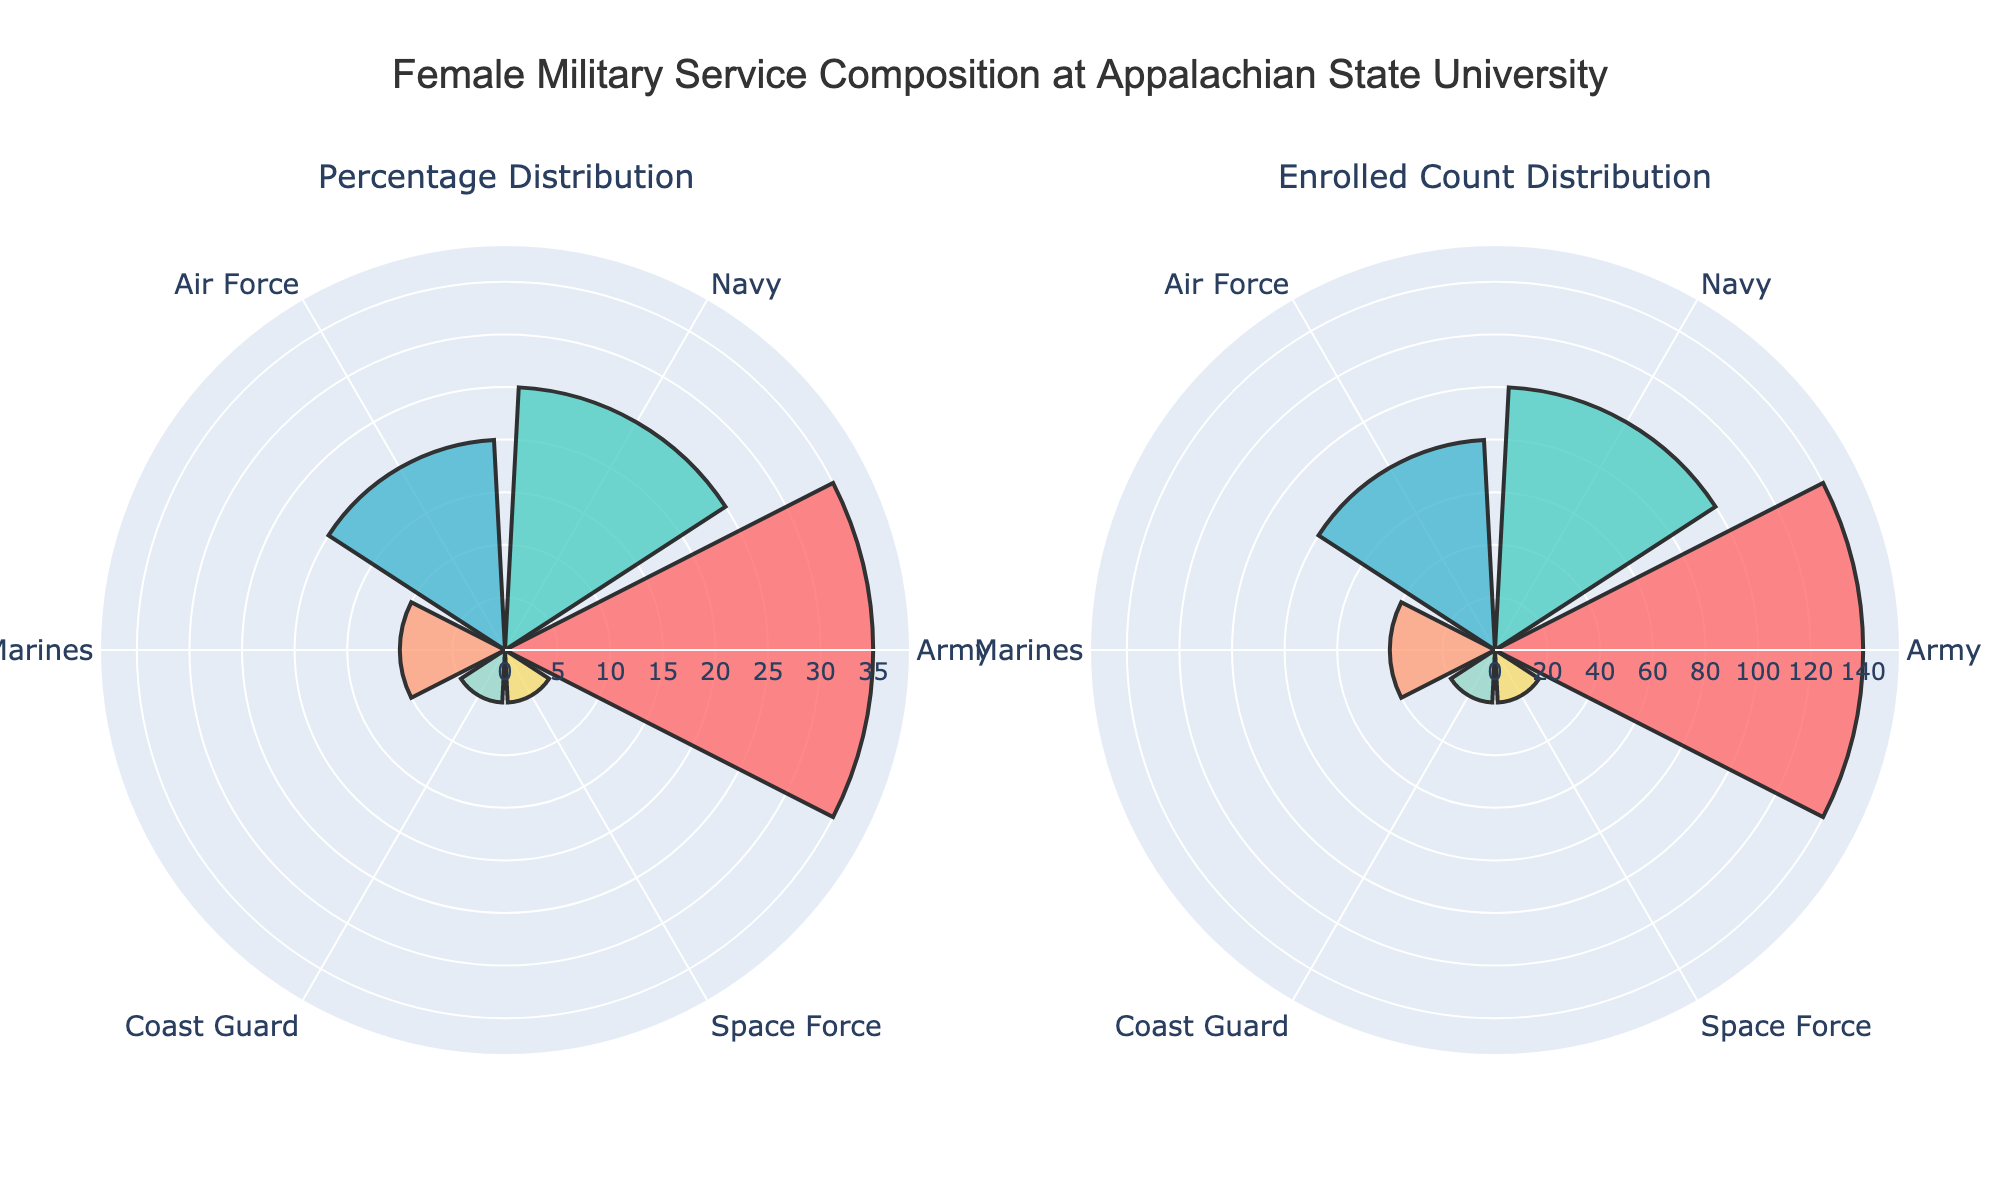How many service branches are represented in the plots? Count the number of different service branches shown in either of the polar charts. Both charts represent the same branches. A quick look shows six different service branches.
Answer: Six What is the highest percentage for any service branch? Look at the "Percentage Distribution" plot and identify the bar with the maximum radial length (height). The Army has the highest bar at 35%.
Answer: 35% Which service branch has the lowest enrolled count? Refer to the "Enrolled Count Distribution" plot and find the bar with the shortest radial length. Both the Coast Guard and Space Force have the lowest counts of 20.
Answer: Coast Guard and Space Force What service branch has the second largest percentage distribution? Identify the second highest bar in the "Percentage Distribution" plot. The Navy has the second largest percentage at 25%.
Answer: Navy What is the total enrolled count across all service branches? Sum the enrolled counts of all the branches from the "Enrolled Count Distribution" plot: 140 (Army) + 100 (Navy) + 80 (Air Force) + 40 (Marines) + 20 (Coast Guard) + 20 (Space Force) = 400.
Answer: 400 Which two service branches have the exact same percentage? Look for identical radial lengths in the "Percentage Distribution" plot. Both the Coast Guard and Space Force have percentages of 5%.
Answer: Coast Guard and Space Force How does the Marines' percentage compare to the Air Force's percentage? Compare the radial lengths of the Marines (10%) and the Air Force (20%) in the "Percentage Distribution" plot. The Air Force's percentage is twice that of the Marines.
Answer: Air Force is higher What's the total percentage of students from the Army and Navy combined? Add the percentages from the "Percentage Distribution" plot: Army (35%) + Navy (25%) = 60%.
Answer: 60% Which service branch has a higher enrolled count, Marines or Air Force? Look at the "Enrolled Count Distribution" plot and compare the radial lengths. The Air Force (80) has a higher enrolled count than the Marines (40).
Answer: Air Force What is the average percentage of all service branches? Calculate the average by summing all the percentages and dividing by the number of branches: (35% + 25% + 20% + 10% + 5% + 5%) / 6 = 16.67%.
Answer: 16.67% 